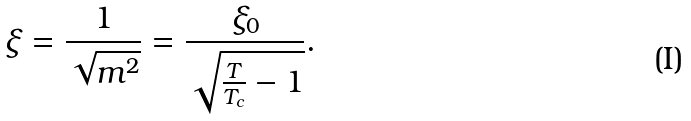<formula> <loc_0><loc_0><loc_500><loc_500>\xi = \frac { 1 } { \sqrt { m ^ { 2 } } } = \frac { \xi _ { 0 } } { \sqrt { \frac { T } { T _ { c } } - 1 } } .</formula> 